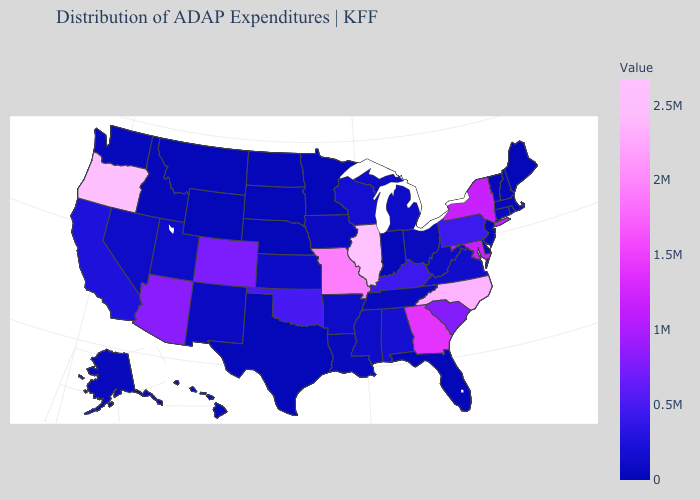Which states hav the highest value in the West?
Quick response, please. Oregon. Does New Hampshire have the lowest value in the USA?
Concise answer only. No. Does Michigan have a lower value than Colorado?
Write a very short answer. Yes. 